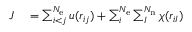Convert formula to latex. <formula><loc_0><loc_0><loc_500><loc_500>\begin{array} { r l } { J } & = \sum _ { i < j } ^ { N _ { e } } u ( r _ { i j } ) + \sum _ { i } ^ { N _ { e } } \sum _ { I } ^ { N _ { n } } \chi ( r _ { i I } ) } \end{array}</formula> 